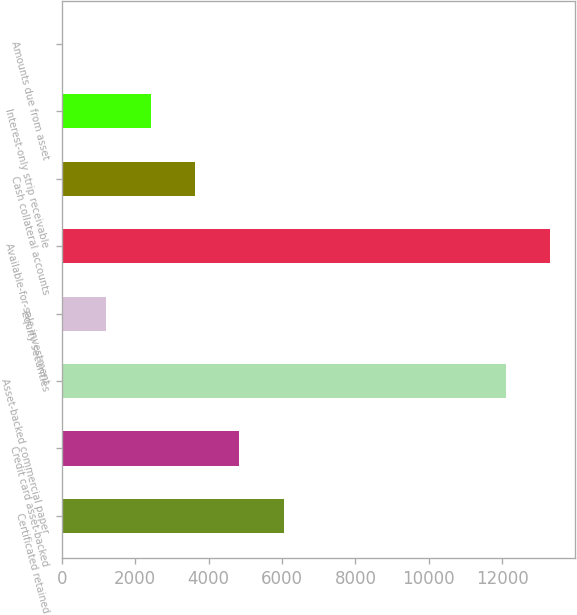<chart> <loc_0><loc_0><loc_500><loc_500><bar_chart><fcel>Certificated retained<fcel>Credit card asset-backed<fcel>Asset-backed commercial paper<fcel>Equity securities<fcel>Available-for-sale investment<fcel>Cash collateral accounts<fcel>Interest-only strip receivable<fcel>Amounts due from asset<nl><fcel>6051.17<fcel>4841.21<fcel>12101<fcel>1211.33<fcel>13311<fcel>3631.25<fcel>2421.29<fcel>1.37<nl></chart> 